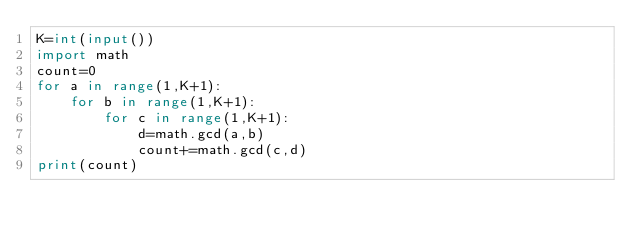<code> <loc_0><loc_0><loc_500><loc_500><_Python_>K=int(input())
import math
count=0
for a in range(1,K+1):
    for b in range(1,K+1):
        for c in range(1,K+1):
            d=math.gcd(a,b)
            count+=math.gcd(c,d)
print(count)</code> 